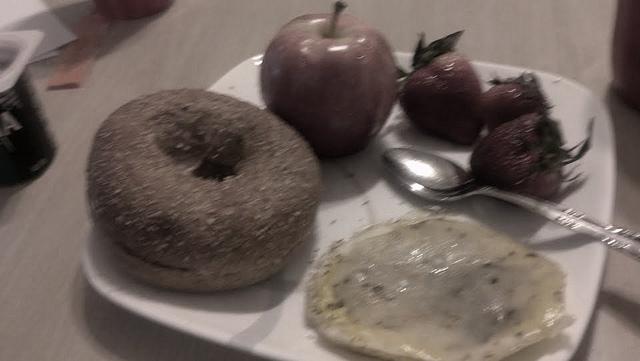Is the image in black and white?
Concise answer only. Yes. What type of bagel is in the meal?
Concise answer only. Wheat. Is this a balanced meal?
Write a very short answer. No. 